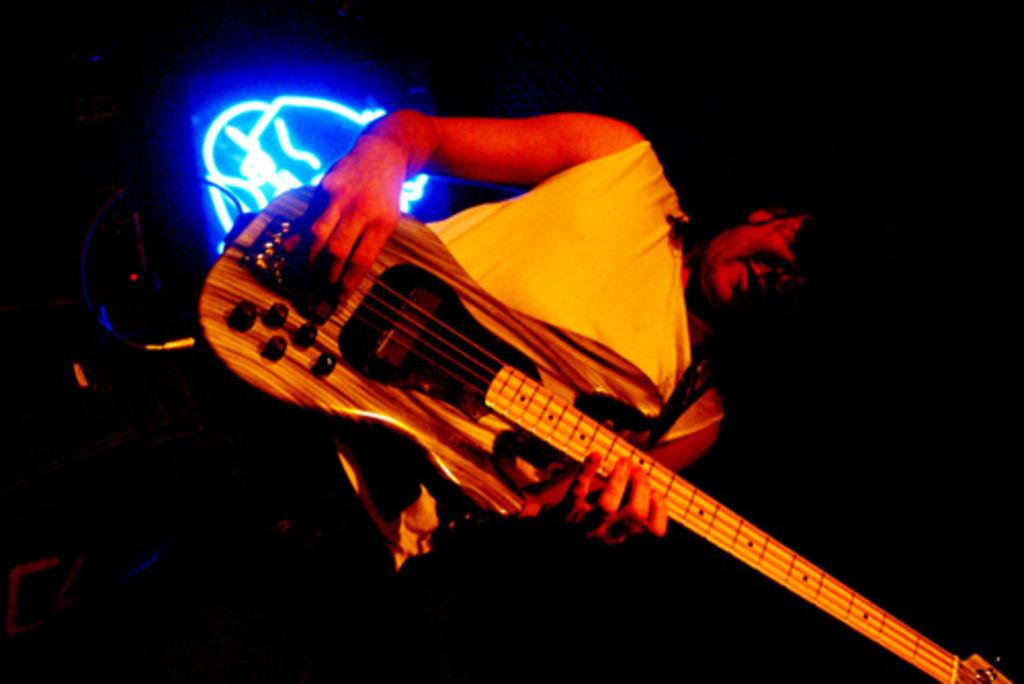What is the person in the image doing? The person is holding a guitar. What object is the person holding in the image? The person is holding a guitar. Can you describe the lighting in the image? There is light visible in the background of the image. What type of wool is being used to attack the person in the image? There is no wool or attack present in the image; it features a person holding a guitar with light visible in the background. 